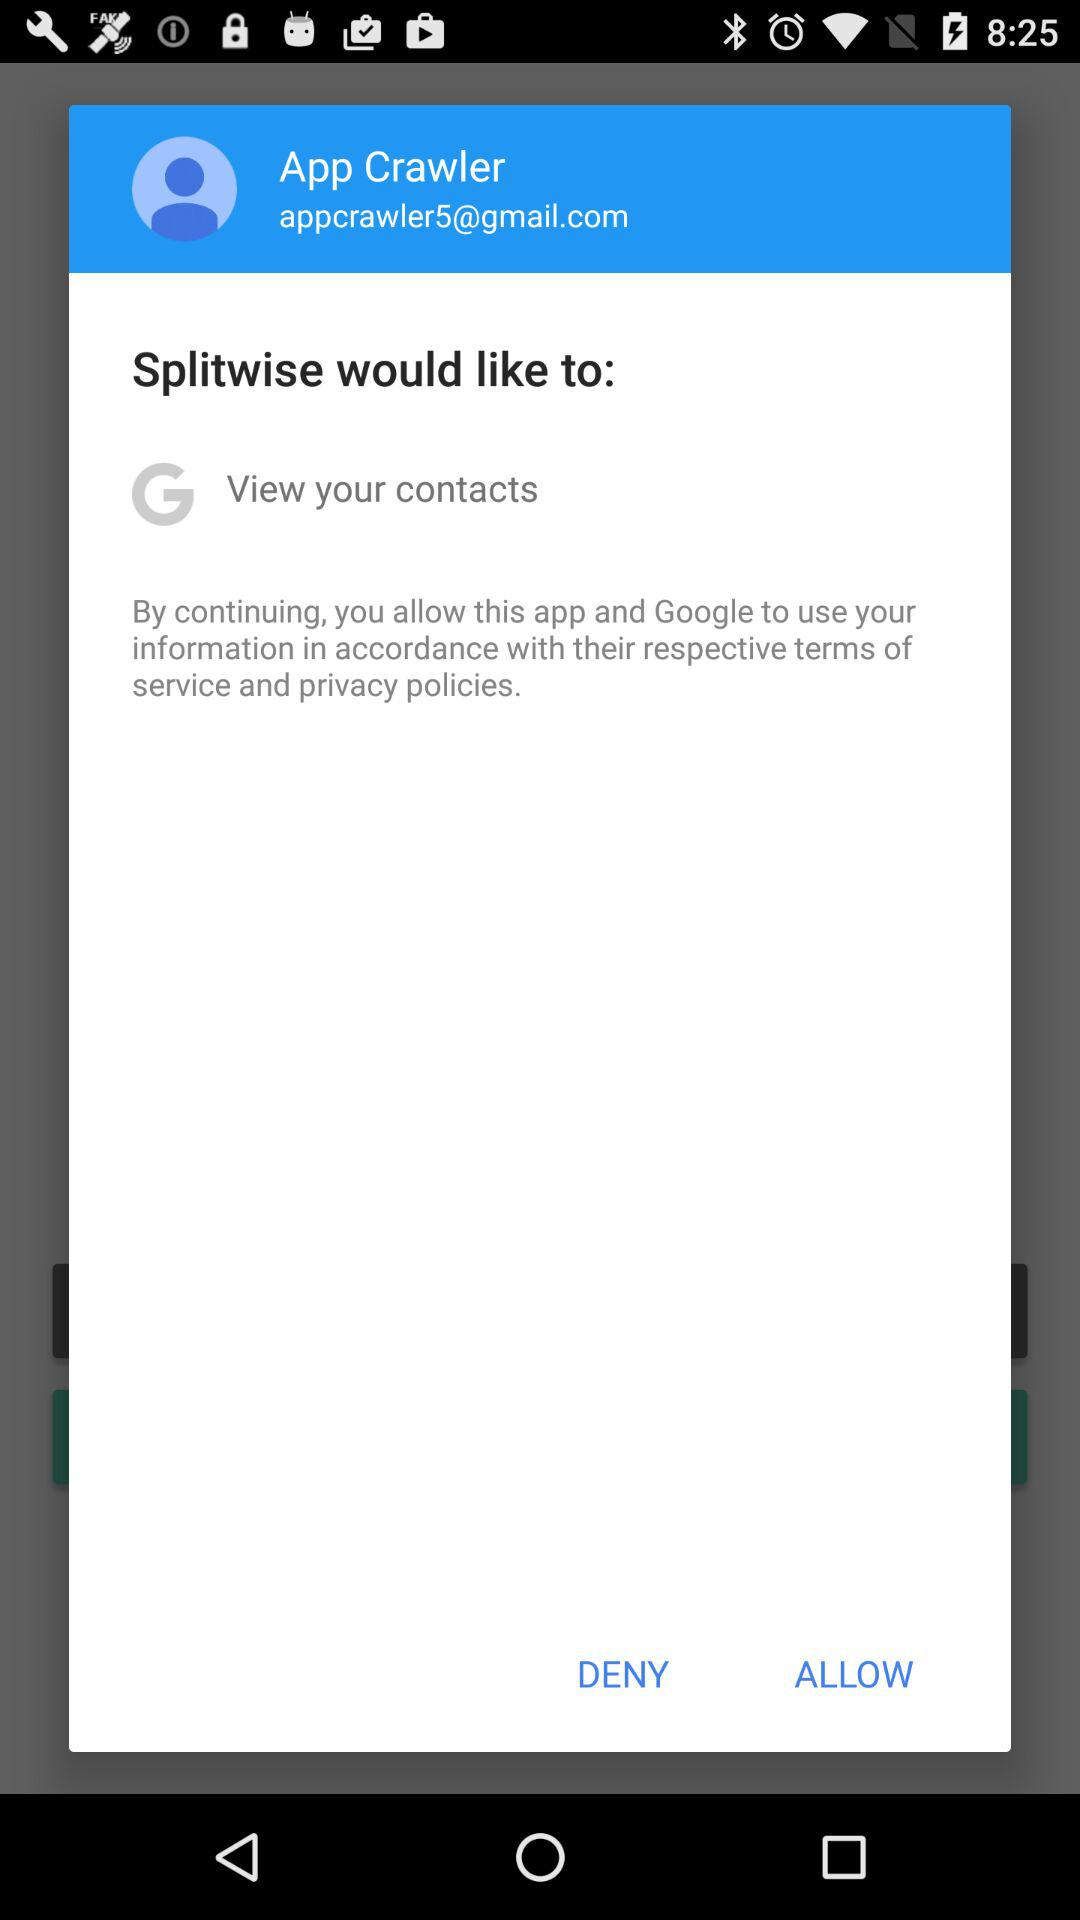What is the email address? The email address is appcrawler5@gmail.com. 